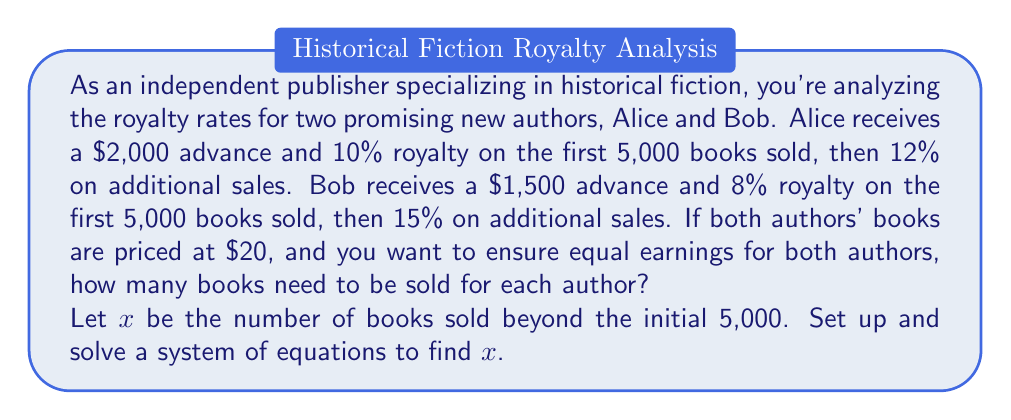Could you help me with this problem? Let's approach this step-by-step:

1) First, let's set up equations for each author's earnings:

   For Alice: $A = 2000 + 0.10 \cdot 20 \cdot 5000 + 0.12 \cdot 20x$
   For Bob: $B = 1500 + 0.08 \cdot 20 \cdot 5000 + 0.15 \cdot 20x$

2) Simplify these equations:

   $A = 2000 + 10000 + 2.4x = 12000 + 2.4x$
   $B = 1500 + 8000 + 3x = 9500 + 3x$

3) For equal earnings, set these equations equal to each other:

   $12000 + 2.4x = 9500 + 3x$

4) Solve for $x$:

   $12000 + 2.4x = 9500 + 3x$
   $2500 = 0.6x$
   $x = \frac{2500}{0.6} = 4166.67$

5) Since we can't sell a fraction of a book, we round up to 4,167.

6) The total number of books sold for each author would be 5,000 + 4,167 = 9,167.

7) To verify, let's calculate the earnings for each author with 9,167 books sold:

   Alice: $12000 + 2.4 \cdot 4167 = 22000.80$
   Bob: $9500 + 3 \cdot 4167 = 22001.00$

   The difference of $0.20 is due to rounding.
Answer: 9,167 books need to be sold for each author to ensure equal earnings. 